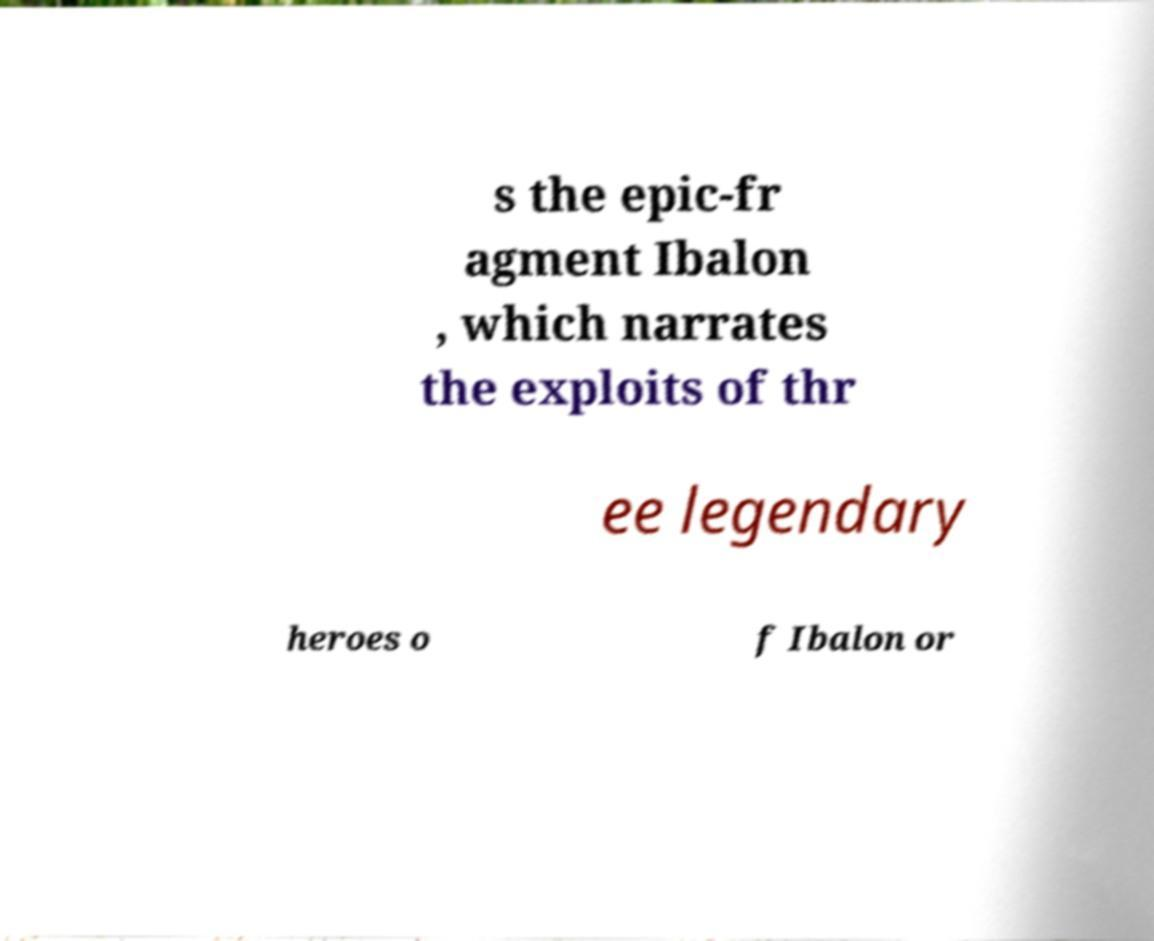Could you assist in decoding the text presented in this image and type it out clearly? s the epic-fr agment Ibalon , which narrates the exploits of thr ee legendary heroes o f Ibalon or 